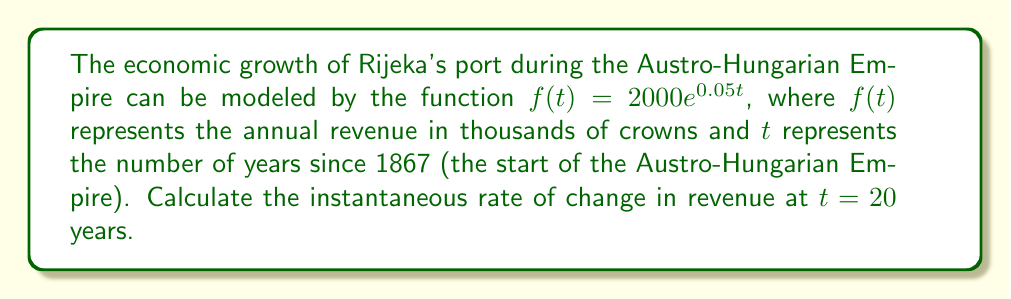Can you solve this math problem? To find the instantaneous rate of change at $t = 20$, we need to calculate the derivative of the function $f(t)$ and evaluate it at $t = 20$.

Step 1: Find the derivative of $f(t)$.
$$f(t) = 2000e^{0.05t}$$
$$f'(t) = 2000 \cdot 0.05e^{0.05t} = 100e^{0.05t}$$

Step 2: Evaluate $f'(t)$ at $t = 20$.
$$f'(20) = 100e^{0.05 \cdot 20}$$
$$f'(20) = 100e^1 = 100e \approx 271.828$$

Step 3: Interpret the result.
The instantaneous rate of change at $t = 20$ is approximately 271.828 thousand crowns per year.
Answer: 271.828 thousand crowns per year 